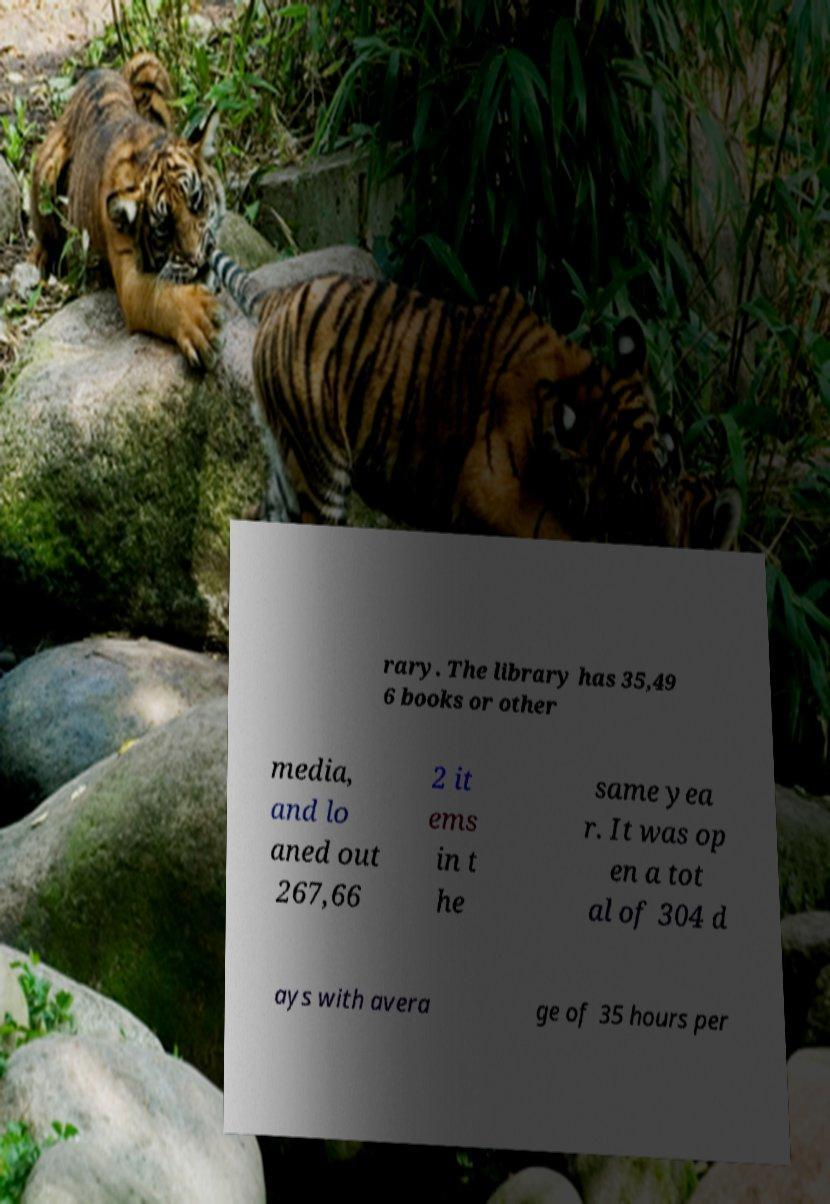There's text embedded in this image that I need extracted. Can you transcribe it verbatim? rary. The library has 35,49 6 books or other media, and lo aned out 267,66 2 it ems in t he same yea r. It was op en a tot al of 304 d ays with avera ge of 35 hours per 